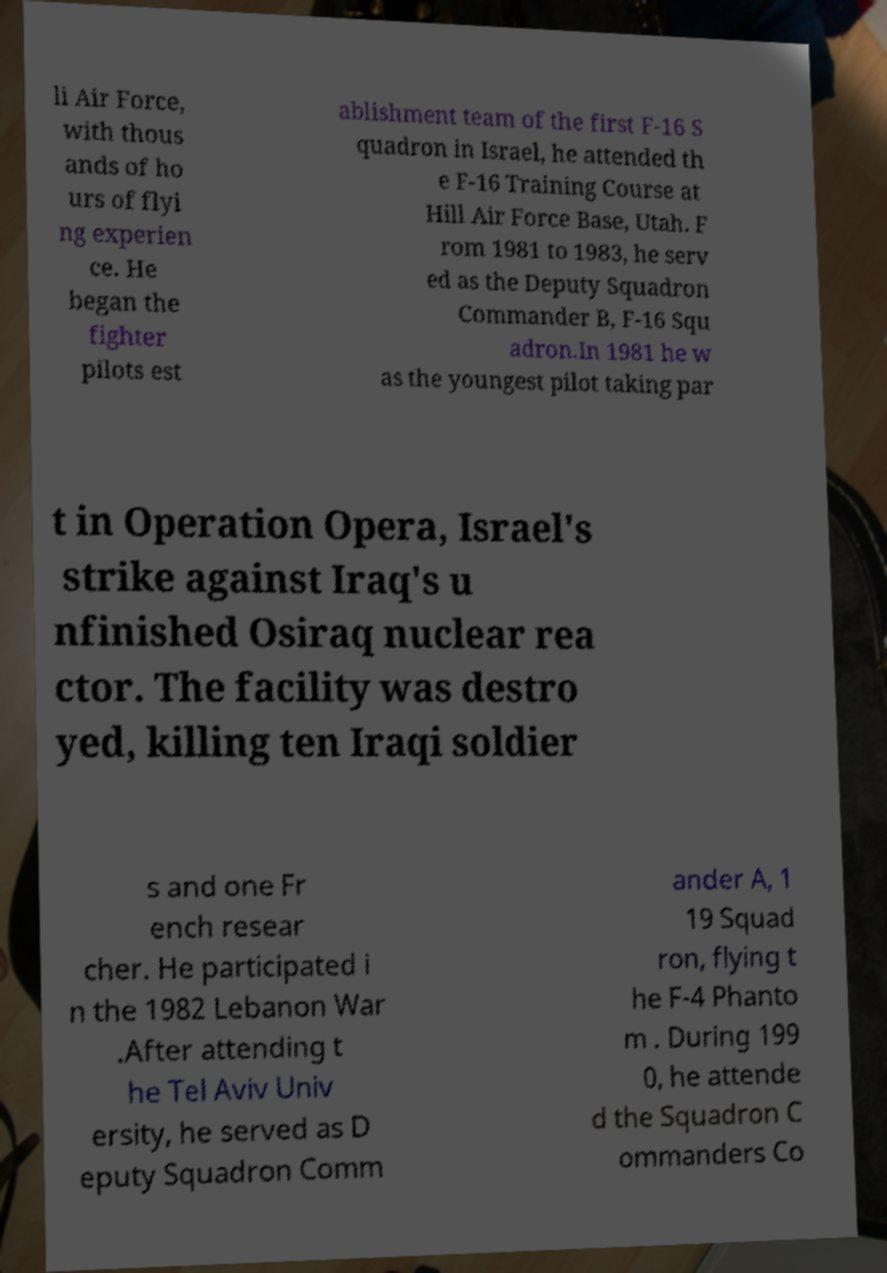Please read and relay the text visible in this image. What does it say? li Air Force, with thous ands of ho urs of flyi ng experien ce. He began the fighter pilots est ablishment team of the first F-16 S quadron in Israel, he attended th e F-16 Training Course at Hill Air Force Base, Utah. F rom 1981 to 1983, he serv ed as the Deputy Squadron Commander B, F-16 Squ adron.In 1981 he w as the youngest pilot taking par t in Operation Opera, Israel's strike against Iraq's u nfinished Osiraq nuclear rea ctor. The facility was destro yed, killing ten Iraqi soldier s and one Fr ench resear cher. He participated i n the 1982 Lebanon War .After attending t he Tel Aviv Univ ersity, he served as D eputy Squadron Comm ander A, 1 19 Squad ron, flying t he F-4 Phanto m . During 199 0, he attende d the Squadron C ommanders Co 